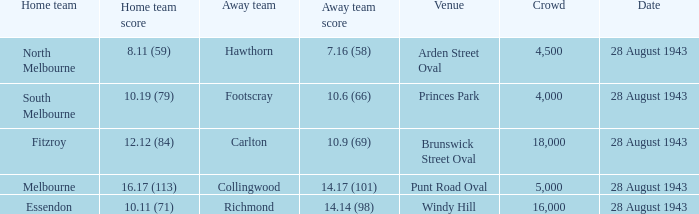What game showed a home team score of 8.11 (59)? 28 August 1943. 